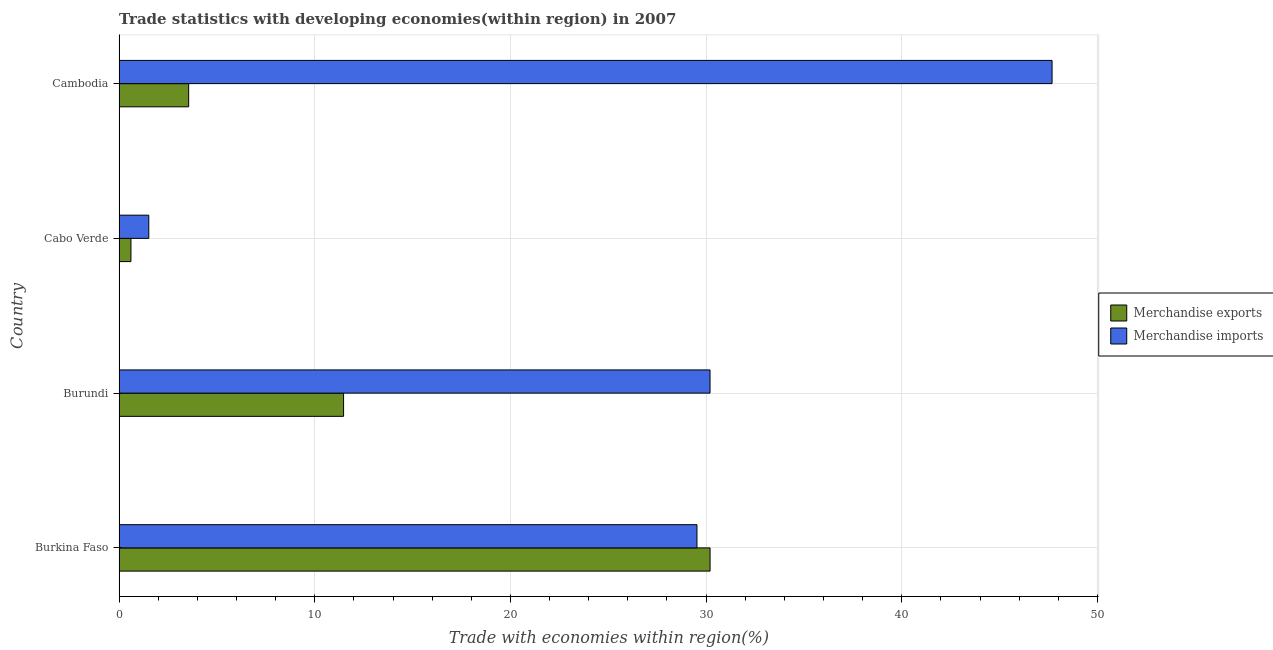How many different coloured bars are there?
Give a very brief answer. 2. How many groups of bars are there?
Make the answer very short. 4. What is the label of the 3rd group of bars from the top?
Your answer should be compact. Burundi. In how many cases, is the number of bars for a given country not equal to the number of legend labels?
Make the answer very short. 0. What is the merchandise imports in Cambodia?
Ensure brevity in your answer.  47.68. Across all countries, what is the maximum merchandise exports?
Provide a short and direct response. 30.2. Across all countries, what is the minimum merchandise imports?
Offer a very short reply. 1.52. In which country was the merchandise exports maximum?
Provide a short and direct response. Burkina Faso. In which country was the merchandise exports minimum?
Give a very brief answer. Cabo Verde. What is the total merchandise imports in the graph?
Ensure brevity in your answer.  108.94. What is the difference between the merchandise imports in Burundi and that in Cabo Verde?
Make the answer very short. 28.68. What is the difference between the merchandise exports in Cambodia and the merchandise imports in Cabo Verde?
Keep it short and to the point. 2.04. What is the average merchandise imports per country?
Your response must be concise. 27.23. What is the difference between the merchandise exports and merchandise imports in Burkina Faso?
Your answer should be compact. 0.67. What is the ratio of the merchandise imports in Burkina Faso to that in Cambodia?
Give a very brief answer. 0.62. Is the merchandise imports in Burkina Faso less than that in Cabo Verde?
Offer a very short reply. No. What is the difference between the highest and the second highest merchandise imports?
Your answer should be compact. 17.48. What is the difference between the highest and the lowest merchandise imports?
Offer a terse response. 46.16. How many bars are there?
Make the answer very short. 8. How many countries are there in the graph?
Your answer should be very brief. 4. What is the difference between two consecutive major ticks on the X-axis?
Your answer should be compact. 10. Does the graph contain any zero values?
Provide a short and direct response. No. How many legend labels are there?
Provide a short and direct response. 2. How are the legend labels stacked?
Give a very brief answer. Vertical. What is the title of the graph?
Make the answer very short. Trade statistics with developing economies(within region) in 2007. Does "Personal remittances" appear as one of the legend labels in the graph?
Give a very brief answer. No. What is the label or title of the X-axis?
Provide a short and direct response. Trade with economies within region(%). What is the label or title of the Y-axis?
Your answer should be compact. Country. What is the Trade with economies within region(%) of Merchandise exports in Burkina Faso?
Make the answer very short. 30.2. What is the Trade with economies within region(%) of Merchandise imports in Burkina Faso?
Offer a terse response. 29.53. What is the Trade with economies within region(%) in Merchandise exports in Burundi?
Offer a terse response. 11.47. What is the Trade with economies within region(%) in Merchandise imports in Burundi?
Offer a very short reply. 30.2. What is the Trade with economies within region(%) in Merchandise exports in Cabo Verde?
Ensure brevity in your answer.  0.61. What is the Trade with economies within region(%) in Merchandise imports in Cabo Verde?
Provide a short and direct response. 1.52. What is the Trade with economies within region(%) in Merchandise exports in Cambodia?
Make the answer very short. 3.56. What is the Trade with economies within region(%) in Merchandise imports in Cambodia?
Make the answer very short. 47.68. Across all countries, what is the maximum Trade with economies within region(%) of Merchandise exports?
Provide a succinct answer. 30.2. Across all countries, what is the maximum Trade with economies within region(%) in Merchandise imports?
Ensure brevity in your answer.  47.68. Across all countries, what is the minimum Trade with economies within region(%) in Merchandise exports?
Give a very brief answer. 0.61. Across all countries, what is the minimum Trade with economies within region(%) of Merchandise imports?
Offer a very short reply. 1.52. What is the total Trade with economies within region(%) in Merchandise exports in the graph?
Your answer should be very brief. 45.84. What is the total Trade with economies within region(%) in Merchandise imports in the graph?
Your answer should be compact. 108.94. What is the difference between the Trade with economies within region(%) in Merchandise exports in Burkina Faso and that in Burundi?
Provide a short and direct response. 18.73. What is the difference between the Trade with economies within region(%) in Merchandise imports in Burkina Faso and that in Burundi?
Your response must be concise. -0.67. What is the difference between the Trade with economies within region(%) in Merchandise exports in Burkina Faso and that in Cabo Verde?
Provide a short and direct response. 29.6. What is the difference between the Trade with economies within region(%) in Merchandise imports in Burkina Faso and that in Cabo Verde?
Provide a succinct answer. 28.01. What is the difference between the Trade with economies within region(%) in Merchandise exports in Burkina Faso and that in Cambodia?
Offer a very short reply. 26.65. What is the difference between the Trade with economies within region(%) of Merchandise imports in Burkina Faso and that in Cambodia?
Your answer should be very brief. -18.15. What is the difference between the Trade with economies within region(%) of Merchandise exports in Burundi and that in Cabo Verde?
Your response must be concise. 10.87. What is the difference between the Trade with economies within region(%) of Merchandise imports in Burundi and that in Cabo Verde?
Offer a very short reply. 28.68. What is the difference between the Trade with economies within region(%) of Merchandise exports in Burundi and that in Cambodia?
Make the answer very short. 7.92. What is the difference between the Trade with economies within region(%) in Merchandise imports in Burundi and that in Cambodia?
Give a very brief answer. -17.48. What is the difference between the Trade with economies within region(%) of Merchandise exports in Cabo Verde and that in Cambodia?
Make the answer very short. -2.95. What is the difference between the Trade with economies within region(%) in Merchandise imports in Cabo Verde and that in Cambodia?
Make the answer very short. -46.16. What is the difference between the Trade with economies within region(%) in Merchandise exports in Burkina Faso and the Trade with economies within region(%) in Merchandise imports in Burundi?
Your response must be concise. 0. What is the difference between the Trade with economies within region(%) of Merchandise exports in Burkina Faso and the Trade with economies within region(%) of Merchandise imports in Cabo Verde?
Keep it short and to the point. 28.68. What is the difference between the Trade with economies within region(%) of Merchandise exports in Burkina Faso and the Trade with economies within region(%) of Merchandise imports in Cambodia?
Provide a succinct answer. -17.48. What is the difference between the Trade with economies within region(%) in Merchandise exports in Burundi and the Trade with economies within region(%) in Merchandise imports in Cabo Verde?
Provide a succinct answer. 9.95. What is the difference between the Trade with economies within region(%) of Merchandise exports in Burundi and the Trade with economies within region(%) of Merchandise imports in Cambodia?
Provide a short and direct response. -36.21. What is the difference between the Trade with economies within region(%) in Merchandise exports in Cabo Verde and the Trade with economies within region(%) in Merchandise imports in Cambodia?
Offer a terse response. -47.07. What is the average Trade with economies within region(%) in Merchandise exports per country?
Offer a very short reply. 11.46. What is the average Trade with economies within region(%) in Merchandise imports per country?
Offer a very short reply. 27.23. What is the difference between the Trade with economies within region(%) of Merchandise exports and Trade with economies within region(%) of Merchandise imports in Burkina Faso?
Your answer should be very brief. 0.67. What is the difference between the Trade with economies within region(%) of Merchandise exports and Trade with economies within region(%) of Merchandise imports in Burundi?
Your answer should be very brief. -18.73. What is the difference between the Trade with economies within region(%) in Merchandise exports and Trade with economies within region(%) in Merchandise imports in Cabo Verde?
Keep it short and to the point. -0.91. What is the difference between the Trade with economies within region(%) in Merchandise exports and Trade with economies within region(%) in Merchandise imports in Cambodia?
Offer a terse response. -44.12. What is the ratio of the Trade with economies within region(%) in Merchandise exports in Burkina Faso to that in Burundi?
Your response must be concise. 2.63. What is the ratio of the Trade with economies within region(%) of Merchandise imports in Burkina Faso to that in Burundi?
Give a very brief answer. 0.98. What is the ratio of the Trade with economies within region(%) of Merchandise exports in Burkina Faso to that in Cabo Verde?
Provide a short and direct response. 49.72. What is the ratio of the Trade with economies within region(%) in Merchandise imports in Burkina Faso to that in Cabo Verde?
Your answer should be very brief. 19.43. What is the ratio of the Trade with economies within region(%) in Merchandise exports in Burkina Faso to that in Cambodia?
Offer a terse response. 8.49. What is the ratio of the Trade with economies within region(%) in Merchandise imports in Burkina Faso to that in Cambodia?
Offer a terse response. 0.62. What is the ratio of the Trade with economies within region(%) in Merchandise exports in Burundi to that in Cabo Verde?
Your answer should be compact. 18.89. What is the ratio of the Trade with economies within region(%) of Merchandise imports in Burundi to that in Cabo Verde?
Your answer should be compact. 19.87. What is the ratio of the Trade with economies within region(%) of Merchandise exports in Burundi to that in Cambodia?
Make the answer very short. 3.23. What is the ratio of the Trade with economies within region(%) in Merchandise imports in Burundi to that in Cambodia?
Keep it short and to the point. 0.63. What is the ratio of the Trade with economies within region(%) in Merchandise exports in Cabo Verde to that in Cambodia?
Keep it short and to the point. 0.17. What is the ratio of the Trade with economies within region(%) in Merchandise imports in Cabo Verde to that in Cambodia?
Your answer should be very brief. 0.03. What is the difference between the highest and the second highest Trade with economies within region(%) of Merchandise exports?
Make the answer very short. 18.73. What is the difference between the highest and the second highest Trade with economies within region(%) in Merchandise imports?
Offer a very short reply. 17.48. What is the difference between the highest and the lowest Trade with economies within region(%) of Merchandise exports?
Ensure brevity in your answer.  29.6. What is the difference between the highest and the lowest Trade with economies within region(%) in Merchandise imports?
Provide a short and direct response. 46.16. 